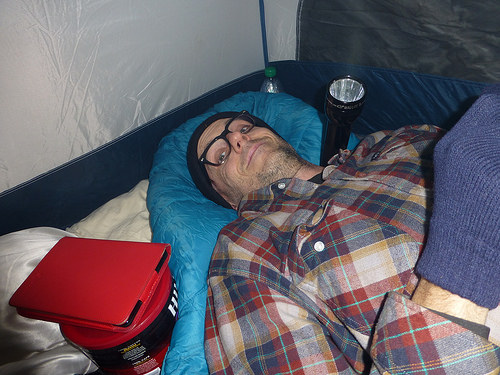<image>
Is there a tablet on the can? Yes. Looking at the image, I can see the tablet is positioned on top of the can, with the can providing support. Is there a man in the sleeping bag? No. The man is not contained within the sleeping bag. These objects have a different spatial relationship. 